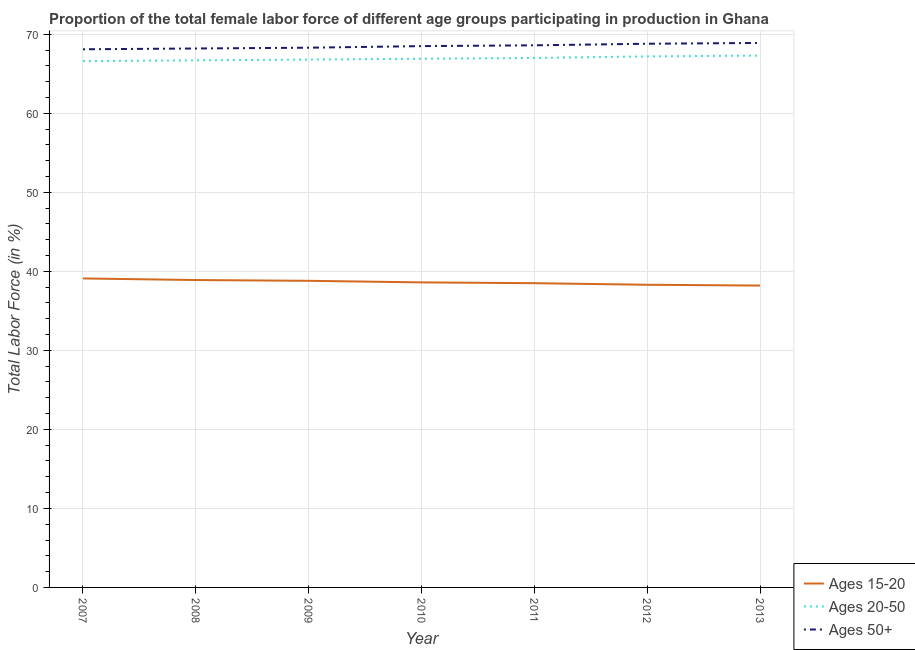How many different coloured lines are there?
Your response must be concise. 3. Does the line corresponding to percentage of female labor force above age 50 intersect with the line corresponding to percentage of female labor force within the age group 15-20?
Give a very brief answer. No. What is the percentage of female labor force within the age group 15-20 in 2012?
Offer a terse response. 38.3. Across all years, what is the maximum percentage of female labor force within the age group 20-50?
Provide a succinct answer. 67.3. Across all years, what is the minimum percentage of female labor force within the age group 20-50?
Offer a very short reply. 66.6. In which year was the percentage of female labor force above age 50 maximum?
Your response must be concise. 2013. In which year was the percentage of female labor force within the age group 20-50 minimum?
Keep it short and to the point. 2007. What is the total percentage of female labor force above age 50 in the graph?
Your answer should be compact. 479.4. What is the difference between the percentage of female labor force above age 50 in 2010 and that in 2012?
Offer a terse response. -0.3. What is the difference between the percentage of female labor force within the age group 15-20 in 2013 and the percentage of female labor force within the age group 20-50 in 2008?
Make the answer very short. -28.5. What is the average percentage of female labor force within the age group 15-20 per year?
Offer a very short reply. 38.63. What is the ratio of the percentage of female labor force within the age group 20-50 in 2009 to that in 2011?
Your answer should be compact. 1. What is the difference between the highest and the second highest percentage of female labor force within the age group 15-20?
Give a very brief answer. 0.2. What is the difference between the highest and the lowest percentage of female labor force above age 50?
Give a very brief answer. 0.8. In how many years, is the percentage of female labor force within the age group 15-20 greater than the average percentage of female labor force within the age group 15-20 taken over all years?
Provide a short and direct response. 3. Does the percentage of female labor force within the age group 20-50 monotonically increase over the years?
Keep it short and to the point. Yes. Is the percentage of female labor force above age 50 strictly less than the percentage of female labor force within the age group 15-20 over the years?
Make the answer very short. No. How many legend labels are there?
Your answer should be very brief. 3. What is the title of the graph?
Offer a terse response. Proportion of the total female labor force of different age groups participating in production in Ghana. Does "Social Protection and Labor" appear as one of the legend labels in the graph?
Your answer should be compact. No. What is the label or title of the Y-axis?
Offer a very short reply. Total Labor Force (in %). What is the Total Labor Force (in %) of Ages 15-20 in 2007?
Ensure brevity in your answer.  39.1. What is the Total Labor Force (in %) in Ages 20-50 in 2007?
Your answer should be very brief. 66.6. What is the Total Labor Force (in %) in Ages 50+ in 2007?
Provide a short and direct response. 68.1. What is the Total Labor Force (in %) in Ages 15-20 in 2008?
Your answer should be compact. 38.9. What is the Total Labor Force (in %) of Ages 20-50 in 2008?
Provide a succinct answer. 66.7. What is the Total Labor Force (in %) in Ages 50+ in 2008?
Provide a succinct answer. 68.2. What is the Total Labor Force (in %) in Ages 15-20 in 2009?
Make the answer very short. 38.8. What is the Total Labor Force (in %) in Ages 20-50 in 2009?
Provide a succinct answer. 66.8. What is the Total Labor Force (in %) in Ages 50+ in 2009?
Your answer should be very brief. 68.3. What is the Total Labor Force (in %) in Ages 15-20 in 2010?
Offer a terse response. 38.6. What is the Total Labor Force (in %) in Ages 20-50 in 2010?
Keep it short and to the point. 66.9. What is the Total Labor Force (in %) of Ages 50+ in 2010?
Ensure brevity in your answer.  68.5. What is the Total Labor Force (in %) of Ages 15-20 in 2011?
Offer a very short reply. 38.5. What is the Total Labor Force (in %) of Ages 20-50 in 2011?
Your answer should be compact. 67. What is the Total Labor Force (in %) in Ages 50+ in 2011?
Offer a very short reply. 68.6. What is the Total Labor Force (in %) of Ages 15-20 in 2012?
Make the answer very short. 38.3. What is the Total Labor Force (in %) in Ages 20-50 in 2012?
Your response must be concise. 67.2. What is the Total Labor Force (in %) of Ages 50+ in 2012?
Provide a short and direct response. 68.8. What is the Total Labor Force (in %) of Ages 15-20 in 2013?
Ensure brevity in your answer.  38.2. What is the Total Labor Force (in %) in Ages 20-50 in 2013?
Offer a terse response. 67.3. What is the Total Labor Force (in %) in Ages 50+ in 2013?
Your answer should be very brief. 68.9. Across all years, what is the maximum Total Labor Force (in %) of Ages 15-20?
Ensure brevity in your answer.  39.1. Across all years, what is the maximum Total Labor Force (in %) of Ages 20-50?
Give a very brief answer. 67.3. Across all years, what is the maximum Total Labor Force (in %) in Ages 50+?
Offer a terse response. 68.9. Across all years, what is the minimum Total Labor Force (in %) in Ages 15-20?
Make the answer very short. 38.2. Across all years, what is the minimum Total Labor Force (in %) in Ages 20-50?
Provide a short and direct response. 66.6. Across all years, what is the minimum Total Labor Force (in %) of Ages 50+?
Provide a succinct answer. 68.1. What is the total Total Labor Force (in %) in Ages 15-20 in the graph?
Offer a very short reply. 270.4. What is the total Total Labor Force (in %) of Ages 20-50 in the graph?
Provide a succinct answer. 468.5. What is the total Total Labor Force (in %) of Ages 50+ in the graph?
Make the answer very short. 479.4. What is the difference between the Total Labor Force (in %) in Ages 15-20 in 2007 and that in 2008?
Make the answer very short. 0.2. What is the difference between the Total Labor Force (in %) in Ages 20-50 in 2007 and that in 2009?
Make the answer very short. -0.2. What is the difference between the Total Labor Force (in %) of Ages 20-50 in 2007 and that in 2010?
Provide a succinct answer. -0.3. What is the difference between the Total Labor Force (in %) in Ages 50+ in 2007 and that in 2010?
Offer a terse response. -0.4. What is the difference between the Total Labor Force (in %) in Ages 20-50 in 2007 and that in 2011?
Your response must be concise. -0.4. What is the difference between the Total Labor Force (in %) in Ages 50+ in 2007 and that in 2011?
Your answer should be very brief. -0.5. What is the difference between the Total Labor Force (in %) of Ages 50+ in 2007 and that in 2012?
Your answer should be compact. -0.7. What is the difference between the Total Labor Force (in %) of Ages 20-50 in 2007 and that in 2013?
Give a very brief answer. -0.7. What is the difference between the Total Labor Force (in %) in Ages 50+ in 2008 and that in 2009?
Give a very brief answer. -0.1. What is the difference between the Total Labor Force (in %) in Ages 20-50 in 2008 and that in 2010?
Keep it short and to the point. -0.2. What is the difference between the Total Labor Force (in %) of Ages 50+ in 2008 and that in 2010?
Your answer should be very brief. -0.3. What is the difference between the Total Labor Force (in %) of Ages 15-20 in 2008 and that in 2011?
Give a very brief answer. 0.4. What is the difference between the Total Labor Force (in %) in Ages 20-50 in 2008 and that in 2011?
Provide a succinct answer. -0.3. What is the difference between the Total Labor Force (in %) of Ages 50+ in 2008 and that in 2013?
Your response must be concise. -0.7. What is the difference between the Total Labor Force (in %) of Ages 15-20 in 2009 and that in 2011?
Keep it short and to the point. 0.3. What is the difference between the Total Labor Force (in %) of Ages 50+ in 2009 and that in 2011?
Keep it short and to the point. -0.3. What is the difference between the Total Labor Force (in %) in Ages 50+ in 2009 and that in 2012?
Ensure brevity in your answer.  -0.5. What is the difference between the Total Labor Force (in %) in Ages 20-50 in 2009 and that in 2013?
Make the answer very short. -0.5. What is the difference between the Total Labor Force (in %) in Ages 50+ in 2009 and that in 2013?
Make the answer very short. -0.6. What is the difference between the Total Labor Force (in %) of Ages 20-50 in 2010 and that in 2011?
Keep it short and to the point. -0.1. What is the difference between the Total Labor Force (in %) in Ages 50+ in 2010 and that in 2011?
Your response must be concise. -0.1. What is the difference between the Total Labor Force (in %) of Ages 20-50 in 2010 and that in 2012?
Your answer should be very brief. -0.3. What is the difference between the Total Labor Force (in %) in Ages 20-50 in 2010 and that in 2013?
Keep it short and to the point. -0.4. What is the difference between the Total Labor Force (in %) in Ages 50+ in 2010 and that in 2013?
Make the answer very short. -0.4. What is the difference between the Total Labor Force (in %) of Ages 15-20 in 2011 and that in 2012?
Provide a succinct answer. 0.2. What is the difference between the Total Labor Force (in %) of Ages 20-50 in 2011 and that in 2012?
Provide a succinct answer. -0.2. What is the difference between the Total Labor Force (in %) in Ages 20-50 in 2011 and that in 2013?
Give a very brief answer. -0.3. What is the difference between the Total Labor Force (in %) of Ages 50+ in 2011 and that in 2013?
Provide a succinct answer. -0.3. What is the difference between the Total Labor Force (in %) in Ages 50+ in 2012 and that in 2013?
Provide a short and direct response. -0.1. What is the difference between the Total Labor Force (in %) of Ages 15-20 in 2007 and the Total Labor Force (in %) of Ages 20-50 in 2008?
Offer a very short reply. -27.6. What is the difference between the Total Labor Force (in %) in Ages 15-20 in 2007 and the Total Labor Force (in %) in Ages 50+ in 2008?
Your answer should be compact. -29.1. What is the difference between the Total Labor Force (in %) in Ages 15-20 in 2007 and the Total Labor Force (in %) in Ages 20-50 in 2009?
Your response must be concise. -27.7. What is the difference between the Total Labor Force (in %) of Ages 15-20 in 2007 and the Total Labor Force (in %) of Ages 50+ in 2009?
Your answer should be compact. -29.2. What is the difference between the Total Labor Force (in %) of Ages 20-50 in 2007 and the Total Labor Force (in %) of Ages 50+ in 2009?
Provide a succinct answer. -1.7. What is the difference between the Total Labor Force (in %) of Ages 15-20 in 2007 and the Total Labor Force (in %) of Ages 20-50 in 2010?
Keep it short and to the point. -27.8. What is the difference between the Total Labor Force (in %) of Ages 15-20 in 2007 and the Total Labor Force (in %) of Ages 50+ in 2010?
Offer a terse response. -29.4. What is the difference between the Total Labor Force (in %) in Ages 20-50 in 2007 and the Total Labor Force (in %) in Ages 50+ in 2010?
Your answer should be compact. -1.9. What is the difference between the Total Labor Force (in %) of Ages 15-20 in 2007 and the Total Labor Force (in %) of Ages 20-50 in 2011?
Ensure brevity in your answer.  -27.9. What is the difference between the Total Labor Force (in %) of Ages 15-20 in 2007 and the Total Labor Force (in %) of Ages 50+ in 2011?
Offer a very short reply. -29.5. What is the difference between the Total Labor Force (in %) in Ages 20-50 in 2007 and the Total Labor Force (in %) in Ages 50+ in 2011?
Provide a succinct answer. -2. What is the difference between the Total Labor Force (in %) of Ages 15-20 in 2007 and the Total Labor Force (in %) of Ages 20-50 in 2012?
Your answer should be very brief. -28.1. What is the difference between the Total Labor Force (in %) of Ages 15-20 in 2007 and the Total Labor Force (in %) of Ages 50+ in 2012?
Ensure brevity in your answer.  -29.7. What is the difference between the Total Labor Force (in %) in Ages 15-20 in 2007 and the Total Labor Force (in %) in Ages 20-50 in 2013?
Provide a succinct answer. -28.2. What is the difference between the Total Labor Force (in %) of Ages 15-20 in 2007 and the Total Labor Force (in %) of Ages 50+ in 2013?
Provide a succinct answer. -29.8. What is the difference between the Total Labor Force (in %) in Ages 20-50 in 2007 and the Total Labor Force (in %) in Ages 50+ in 2013?
Provide a succinct answer. -2.3. What is the difference between the Total Labor Force (in %) in Ages 15-20 in 2008 and the Total Labor Force (in %) in Ages 20-50 in 2009?
Keep it short and to the point. -27.9. What is the difference between the Total Labor Force (in %) of Ages 15-20 in 2008 and the Total Labor Force (in %) of Ages 50+ in 2009?
Provide a short and direct response. -29.4. What is the difference between the Total Labor Force (in %) of Ages 20-50 in 2008 and the Total Labor Force (in %) of Ages 50+ in 2009?
Give a very brief answer. -1.6. What is the difference between the Total Labor Force (in %) of Ages 15-20 in 2008 and the Total Labor Force (in %) of Ages 20-50 in 2010?
Provide a short and direct response. -28. What is the difference between the Total Labor Force (in %) of Ages 15-20 in 2008 and the Total Labor Force (in %) of Ages 50+ in 2010?
Offer a very short reply. -29.6. What is the difference between the Total Labor Force (in %) in Ages 20-50 in 2008 and the Total Labor Force (in %) in Ages 50+ in 2010?
Provide a short and direct response. -1.8. What is the difference between the Total Labor Force (in %) of Ages 15-20 in 2008 and the Total Labor Force (in %) of Ages 20-50 in 2011?
Make the answer very short. -28.1. What is the difference between the Total Labor Force (in %) of Ages 15-20 in 2008 and the Total Labor Force (in %) of Ages 50+ in 2011?
Ensure brevity in your answer.  -29.7. What is the difference between the Total Labor Force (in %) in Ages 15-20 in 2008 and the Total Labor Force (in %) in Ages 20-50 in 2012?
Keep it short and to the point. -28.3. What is the difference between the Total Labor Force (in %) in Ages 15-20 in 2008 and the Total Labor Force (in %) in Ages 50+ in 2012?
Keep it short and to the point. -29.9. What is the difference between the Total Labor Force (in %) in Ages 20-50 in 2008 and the Total Labor Force (in %) in Ages 50+ in 2012?
Your answer should be very brief. -2.1. What is the difference between the Total Labor Force (in %) of Ages 15-20 in 2008 and the Total Labor Force (in %) of Ages 20-50 in 2013?
Offer a very short reply. -28.4. What is the difference between the Total Labor Force (in %) in Ages 15-20 in 2008 and the Total Labor Force (in %) in Ages 50+ in 2013?
Offer a very short reply. -30. What is the difference between the Total Labor Force (in %) of Ages 20-50 in 2008 and the Total Labor Force (in %) of Ages 50+ in 2013?
Provide a succinct answer. -2.2. What is the difference between the Total Labor Force (in %) in Ages 15-20 in 2009 and the Total Labor Force (in %) in Ages 20-50 in 2010?
Your answer should be very brief. -28.1. What is the difference between the Total Labor Force (in %) of Ages 15-20 in 2009 and the Total Labor Force (in %) of Ages 50+ in 2010?
Your response must be concise. -29.7. What is the difference between the Total Labor Force (in %) of Ages 15-20 in 2009 and the Total Labor Force (in %) of Ages 20-50 in 2011?
Your answer should be compact. -28.2. What is the difference between the Total Labor Force (in %) of Ages 15-20 in 2009 and the Total Labor Force (in %) of Ages 50+ in 2011?
Make the answer very short. -29.8. What is the difference between the Total Labor Force (in %) in Ages 20-50 in 2009 and the Total Labor Force (in %) in Ages 50+ in 2011?
Your response must be concise. -1.8. What is the difference between the Total Labor Force (in %) of Ages 15-20 in 2009 and the Total Labor Force (in %) of Ages 20-50 in 2012?
Your answer should be compact. -28.4. What is the difference between the Total Labor Force (in %) of Ages 15-20 in 2009 and the Total Labor Force (in %) of Ages 50+ in 2012?
Give a very brief answer. -30. What is the difference between the Total Labor Force (in %) in Ages 15-20 in 2009 and the Total Labor Force (in %) in Ages 20-50 in 2013?
Offer a very short reply. -28.5. What is the difference between the Total Labor Force (in %) of Ages 15-20 in 2009 and the Total Labor Force (in %) of Ages 50+ in 2013?
Provide a succinct answer. -30.1. What is the difference between the Total Labor Force (in %) of Ages 15-20 in 2010 and the Total Labor Force (in %) of Ages 20-50 in 2011?
Offer a very short reply. -28.4. What is the difference between the Total Labor Force (in %) of Ages 15-20 in 2010 and the Total Labor Force (in %) of Ages 50+ in 2011?
Keep it short and to the point. -30. What is the difference between the Total Labor Force (in %) in Ages 20-50 in 2010 and the Total Labor Force (in %) in Ages 50+ in 2011?
Your response must be concise. -1.7. What is the difference between the Total Labor Force (in %) in Ages 15-20 in 2010 and the Total Labor Force (in %) in Ages 20-50 in 2012?
Provide a succinct answer. -28.6. What is the difference between the Total Labor Force (in %) of Ages 15-20 in 2010 and the Total Labor Force (in %) of Ages 50+ in 2012?
Provide a short and direct response. -30.2. What is the difference between the Total Labor Force (in %) of Ages 15-20 in 2010 and the Total Labor Force (in %) of Ages 20-50 in 2013?
Offer a terse response. -28.7. What is the difference between the Total Labor Force (in %) of Ages 15-20 in 2010 and the Total Labor Force (in %) of Ages 50+ in 2013?
Ensure brevity in your answer.  -30.3. What is the difference between the Total Labor Force (in %) of Ages 15-20 in 2011 and the Total Labor Force (in %) of Ages 20-50 in 2012?
Keep it short and to the point. -28.7. What is the difference between the Total Labor Force (in %) of Ages 15-20 in 2011 and the Total Labor Force (in %) of Ages 50+ in 2012?
Your response must be concise. -30.3. What is the difference between the Total Labor Force (in %) in Ages 15-20 in 2011 and the Total Labor Force (in %) in Ages 20-50 in 2013?
Give a very brief answer. -28.8. What is the difference between the Total Labor Force (in %) in Ages 15-20 in 2011 and the Total Labor Force (in %) in Ages 50+ in 2013?
Ensure brevity in your answer.  -30.4. What is the difference between the Total Labor Force (in %) in Ages 15-20 in 2012 and the Total Labor Force (in %) in Ages 50+ in 2013?
Your answer should be very brief. -30.6. What is the average Total Labor Force (in %) of Ages 15-20 per year?
Provide a succinct answer. 38.63. What is the average Total Labor Force (in %) of Ages 20-50 per year?
Make the answer very short. 66.93. What is the average Total Labor Force (in %) in Ages 50+ per year?
Your answer should be very brief. 68.49. In the year 2007, what is the difference between the Total Labor Force (in %) in Ages 15-20 and Total Labor Force (in %) in Ages 20-50?
Your response must be concise. -27.5. In the year 2008, what is the difference between the Total Labor Force (in %) in Ages 15-20 and Total Labor Force (in %) in Ages 20-50?
Keep it short and to the point. -27.8. In the year 2008, what is the difference between the Total Labor Force (in %) in Ages 15-20 and Total Labor Force (in %) in Ages 50+?
Your response must be concise. -29.3. In the year 2008, what is the difference between the Total Labor Force (in %) of Ages 20-50 and Total Labor Force (in %) of Ages 50+?
Your answer should be compact. -1.5. In the year 2009, what is the difference between the Total Labor Force (in %) in Ages 15-20 and Total Labor Force (in %) in Ages 20-50?
Give a very brief answer. -28. In the year 2009, what is the difference between the Total Labor Force (in %) in Ages 15-20 and Total Labor Force (in %) in Ages 50+?
Keep it short and to the point. -29.5. In the year 2009, what is the difference between the Total Labor Force (in %) in Ages 20-50 and Total Labor Force (in %) in Ages 50+?
Your response must be concise. -1.5. In the year 2010, what is the difference between the Total Labor Force (in %) in Ages 15-20 and Total Labor Force (in %) in Ages 20-50?
Offer a very short reply. -28.3. In the year 2010, what is the difference between the Total Labor Force (in %) in Ages 15-20 and Total Labor Force (in %) in Ages 50+?
Give a very brief answer. -29.9. In the year 2010, what is the difference between the Total Labor Force (in %) in Ages 20-50 and Total Labor Force (in %) in Ages 50+?
Provide a succinct answer. -1.6. In the year 2011, what is the difference between the Total Labor Force (in %) of Ages 15-20 and Total Labor Force (in %) of Ages 20-50?
Offer a very short reply. -28.5. In the year 2011, what is the difference between the Total Labor Force (in %) in Ages 15-20 and Total Labor Force (in %) in Ages 50+?
Your answer should be compact. -30.1. In the year 2011, what is the difference between the Total Labor Force (in %) of Ages 20-50 and Total Labor Force (in %) of Ages 50+?
Keep it short and to the point. -1.6. In the year 2012, what is the difference between the Total Labor Force (in %) of Ages 15-20 and Total Labor Force (in %) of Ages 20-50?
Your response must be concise. -28.9. In the year 2012, what is the difference between the Total Labor Force (in %) in Ages 15-20 and Total Labor Force (in %) in Ages 50+?
Provide a succinct answer. -30.5. In the year 2013, what is the difference between the Total Labor Force (in %) of Ages 15-20 and Total Labor Force (in %) of Ages 20-50?
Offer a very short reply. -29.1. In the year 2013, what is the difference between the Total Labor Force (in %) in Ages 15-20 and Total Labor Force (in %) in Ages 50+?
Make the answer very short. -30.7. What is the ratio of the Total Labor Force (in %) in Ages 50+ in 2007 to that in 2008?
Ensure brevity in your answer.  1. What is the ratio of the Total Labor Force (in %) of Ages 15-20 in 2007 to that in 2009?
Provide a short and direct response. 1.01. What is the ratio of the Total Labor Force (in %) of Ages 20-50 in 2007 to that in 2009?
Offer a terse response. 1. What is the ratio of the Total Labor Force (in %) of Ages 50+ in 2007 to that in 2009?
Make the answer very short. 1. What is the ratio of the Total Labor Force (in %) in Ages 15-20 in 2007 to that in 2010?
Keep it short and to the point. 1.01. What is the ratio of the Total Labor Force (in %) in Ages 15-20 in 2007 to that in 2011?
Offer a terse response. 1.02. What is the ratio of the Total Labor Force (in %) in Ages 20-50 in 2007 to that in 2011?
Your answer should be very brief. 0.99. What is the ratio of the Total Labor Force (in %) of Ages 15-20 in 2007 to that in 2012?
Ensure brevity in your answer.  1.02. What is the ratio of the Total Labor Force (in %) in Ages 20-50 in 2007 to that in 2012?
Provide a succinct answer. 0.99. What is the ratio of the Total Labor Force (in %) in Ages 15-20 in 2007 to that in 2013?
Provide a succinct answer. 1.02. What is the ratio of the Total Labor Force (in %) of Ages 50+ in 2007 to that in 2013?
Keep it short and to the point. 0.99. What is the ratio of the Total Labor Force (in %) of Ages 15-20 in 2008 to that in 2009?
Provide a short and direct response. 1. What is the ratio of the Total Labor Force (in %) in Ages 20-50 in 2008 to that in 2009?
Offer a very short reply. 1. What is the ratio of the Total Labor Force (in %) in Ages 20-50 in 2008 to that in 2010?
Provide a succinct answer. 1. What is the ratio of the Total Labor Force (in %) of Ages 50+ in 2008 to that in 2010?
Provide a succinct answer. 1. What is the ratio of the Total Labor Force (in %) in Ages 15-20 in 2008 to that in 2011?
Give a very brief answer. 1.01. What is the ratio of the Total Labor Force (in %) in Ages 50+ in 2008 to that in 2011?
Offer a very short reply. 0.99. What is the ratio of the Total Labor Force (in %) in Ages 15-20 in 2008 to that in 2012?
Offer a terse response. 1.02. What is the ratio of the Total Labor Force (in %) of Ages 50+ in 2008 to that in 2012?
Give a very brief answer. 0.99. What is the ratio of the Total Labor Force (in %) of Ages 15-20 in 2008 to that in 2013?
Provide a short and direct response. 1.02. What is the ratio of the Total Labor Force (in %) of Ages 15-20 in 2009 to that in 2010?
Offer a terse response. 1.01. What is the ratio of the Total Labor Force (in %) of Ages 20-50 in 2009 to that in 2010?
Give a very brief answer. 1. What is the ratio of the Total Labor Force (in %) in Ages 50+ in 2009 to that in 2010?
Provide a short and direct response. 1. What is the ratio of the Total Labor Force (in %) in Ages 15-20 in 2009 to that in 2011?
Make the answer very short. 1.01. What is the ratio of the Total Labor Force (in %) of Ages 20-50 in 2009 to that in 2011?
Make the answer very short. 1. What is the ratio of the Total Labor Force (in %) in Ages 15-20 in 2009 to that in 2012?
Keep it short and to the point. 1.01. What is the ratio of the Total Labor Force (in %) of Ages 50+ in 2009 to that in 2012?
Keep it short and to the point. 0.99. What is the ratio of the Total Labor Force (in %) of Ages 15-20 in 2009 to that in 2013?
Keep it short and to the point. 1.02. What is the ratio of the Total Labor Force (in %) of Ages 15-20 in 2010 to that in 2013?
Your response must be concise. 1.01. What is the ratio of the Total Labor Force (in %) of Ages 20-50 in 2011 to that in 2012?
Give a very brief answer. 1. What is the ratio of the Total Labor Force (in %) in Ages 15-20 in 2011 to that in 2013?
Give a very brief answer. 1.01. What is the ratio of the Total Labor Force (in %) of Ages 20-50 in 2011 to that in 2013?
Give a very brief answer. 1. What is the ratio of the Total Labor Force (in %) in Ages 15-20 in 2012 to that in 2013?
Provide a short and direct response. 1. What is the ratio of the Total Labor Force (in %) in Ages 20-50 in 2012 to that in 2013?
Make the answer very short. 1. What is the ratio of the Total Labor Force (in %) in Ages 50+ in 2012 to that in 2013?
Ensure brevity in your answer.  1. What is the difference between the highest and the second highest Total Labor Force (in %) in Ages 20-50?
Your response must be concise. 0.1. What is the difference between the highest and the second highest Total Labor Force (in %) in Ages 50+?
Offer a terse response. 0.1. What is the difference between the highest and the lowest Total Labor Force (in %) in Ages 15-20?
Provide a short and direct response. 0.9. What is the difference between the highest and the lowest Total Labor Force (in %) in Ages 20-50?
Keep it short and to the point. 0.7. 